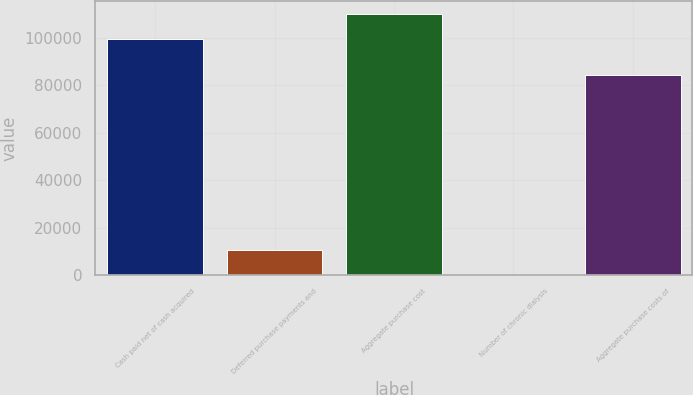<chart> <loc_0><loc_0><loc_500><loc_500><bar_chart><fcel>Cash paid net of cash acquired<fcel>Deferred purchase payments and<fcel>Aggregate purchase cost<fcel>Number of chronic dialysis<fcel>Aggregate purchase costs of<nl><fcel>99645<fcel>10503.4<fcel>110121<fcel>27<fcel>84102<nl></chart> 